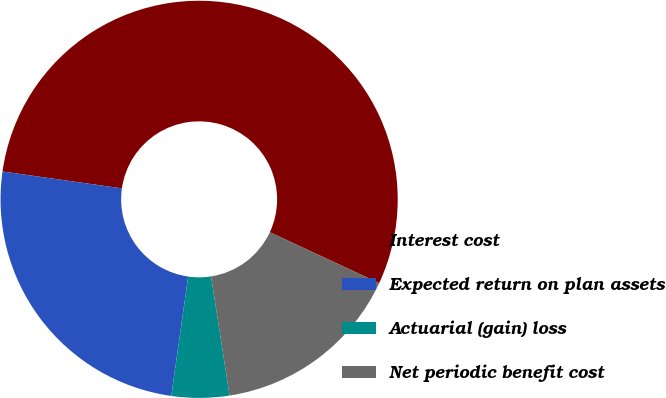Convert chart to OTSL. <chart><loc_0><loc_0><loc_500><loc_500><pie_chart><fcel>Interest cost<fcel>Expected return on plan assets<fcel>Actuarial (gain) loss<fcel>Net periodic benefit cost<nl><fcel>54.69%<fcel>25.0%<fcel>4.69%<fcel>15.62%<nl></chart> 